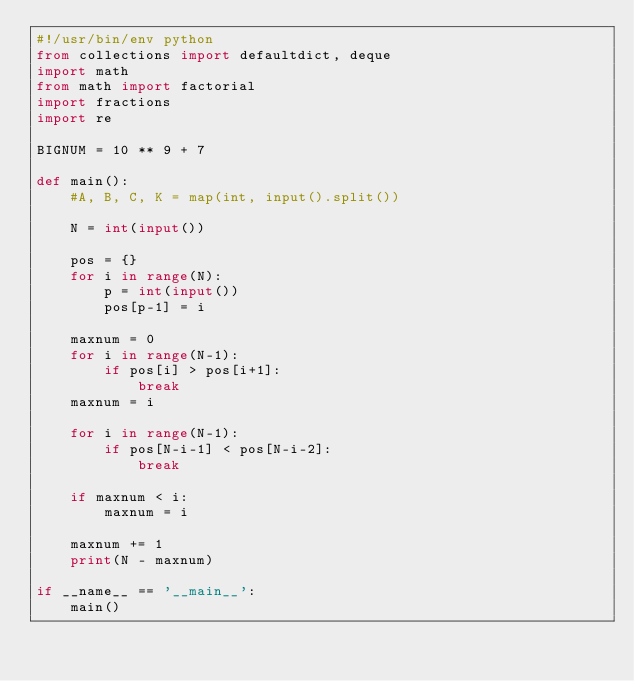Convert code to text. <code><loc_0><loc_0><loc_500><loc_500><_Python_>#!/usr/bin/env python
from collections import defaultdict, deque
import math
from math import factorial
import fractions
import re

BIGNUM = 10 ** 9 + 7

def main():
    #A, B, C, K = map(int, input().split())

    N = int(input())

    pos = {}
    for i in range(N):
        p = int(input())
        pos[p-1] = i

    maxnum = 0
    for i in range(N-1):
        if pos[i] > pos[i+1]:
            break
    maxnum = i

    for i in range(N-1):
        if pos[N-i-1] < pos[N-i-2]:
            break

    if maxnum < i:
        maxnum = i

    maxnum += 1
    print(N - maxnum)

if __name__ == '__main__':
    main()
</code> 